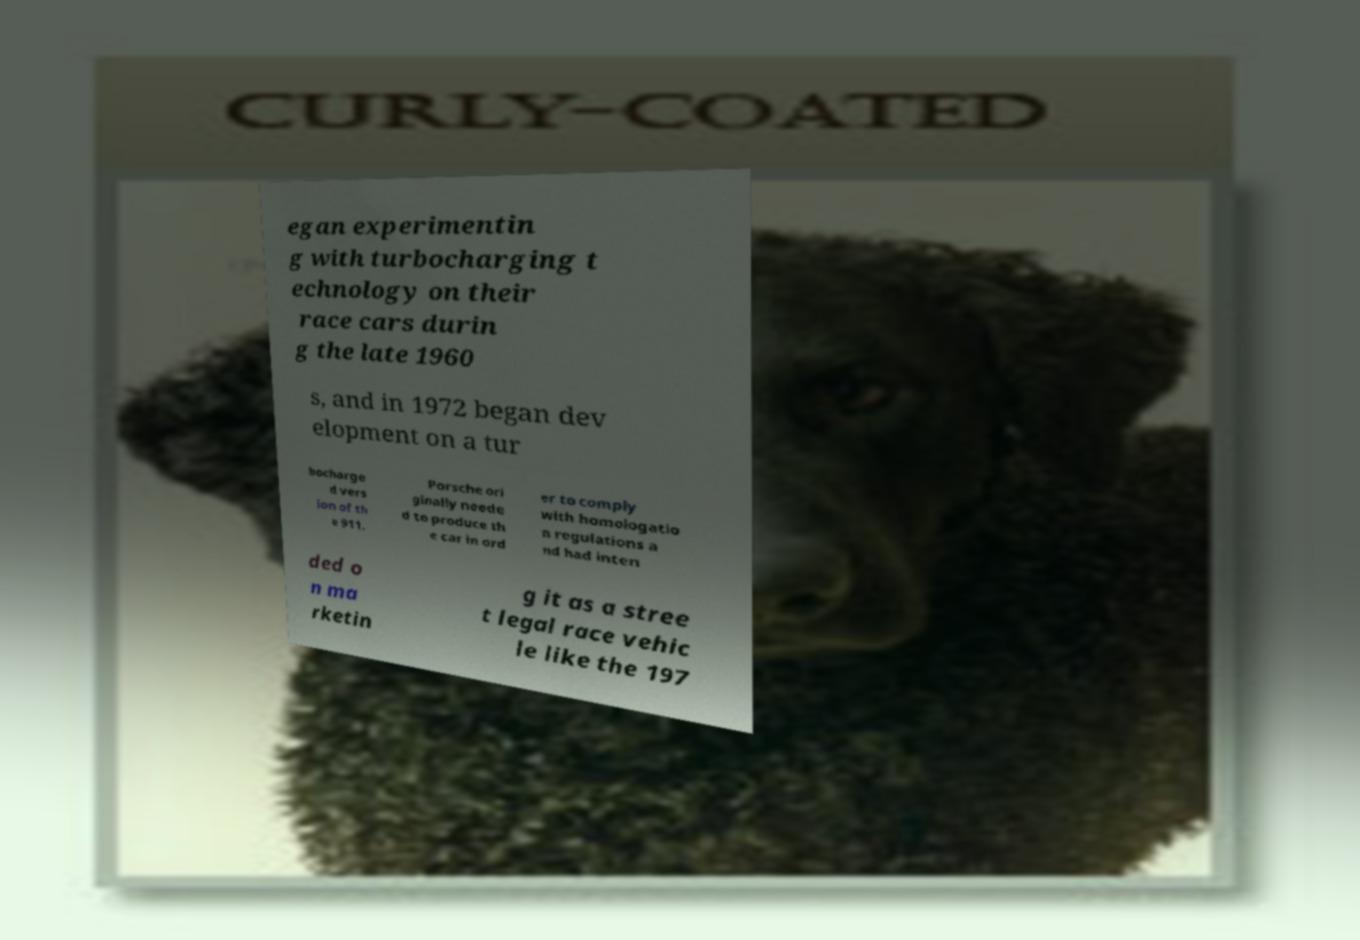Please identify and transcribe the text found in this image. egan experimentin g with turbocharging t echnology on their race cars durin g the late 1960 s, and in 1972 began dev elopment on a tur bocharge d vers ion of th e 911. Porsche ori ginally neede d to produce th e car in ord er to comply with homologatio n regulations a nd had inten ded o n ma rketin g it as a stree t legal race vehic le like the 197 